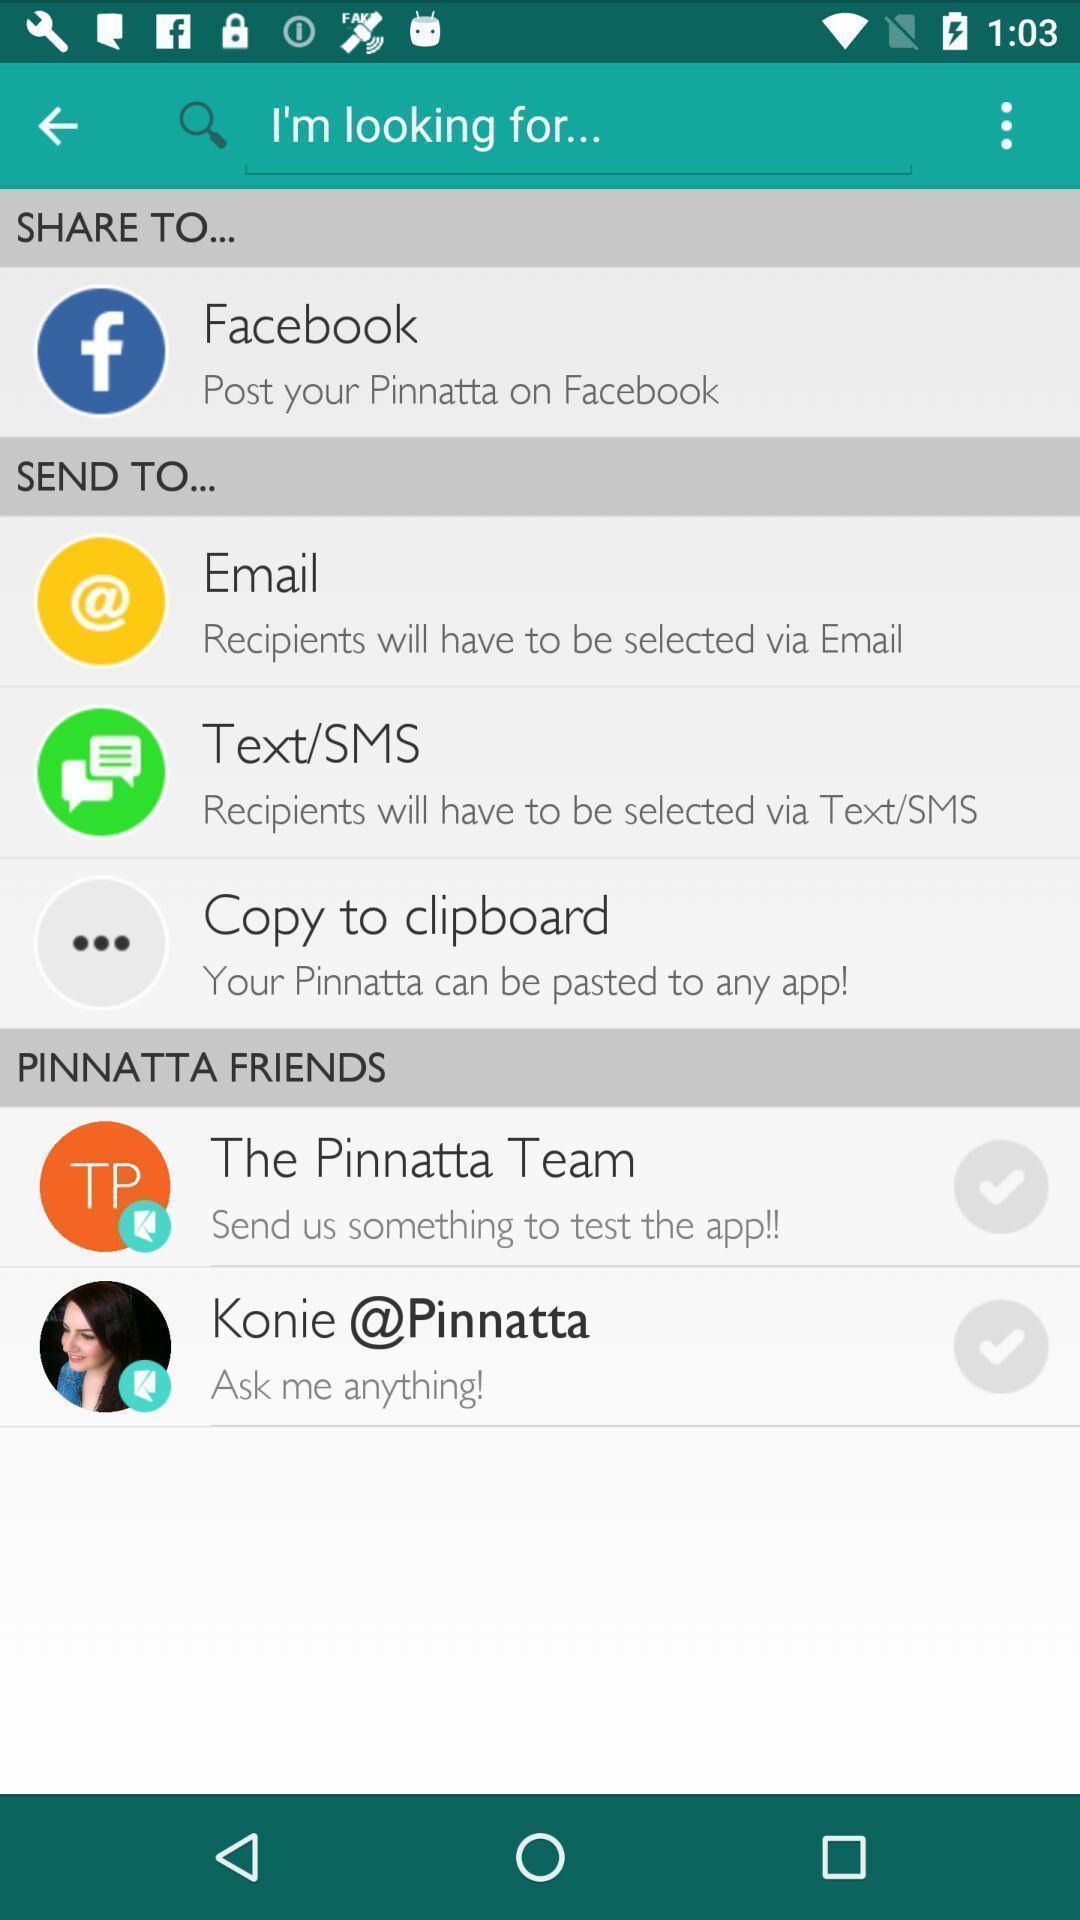Describe the key features of this screenshot. Search page for the social media app. 